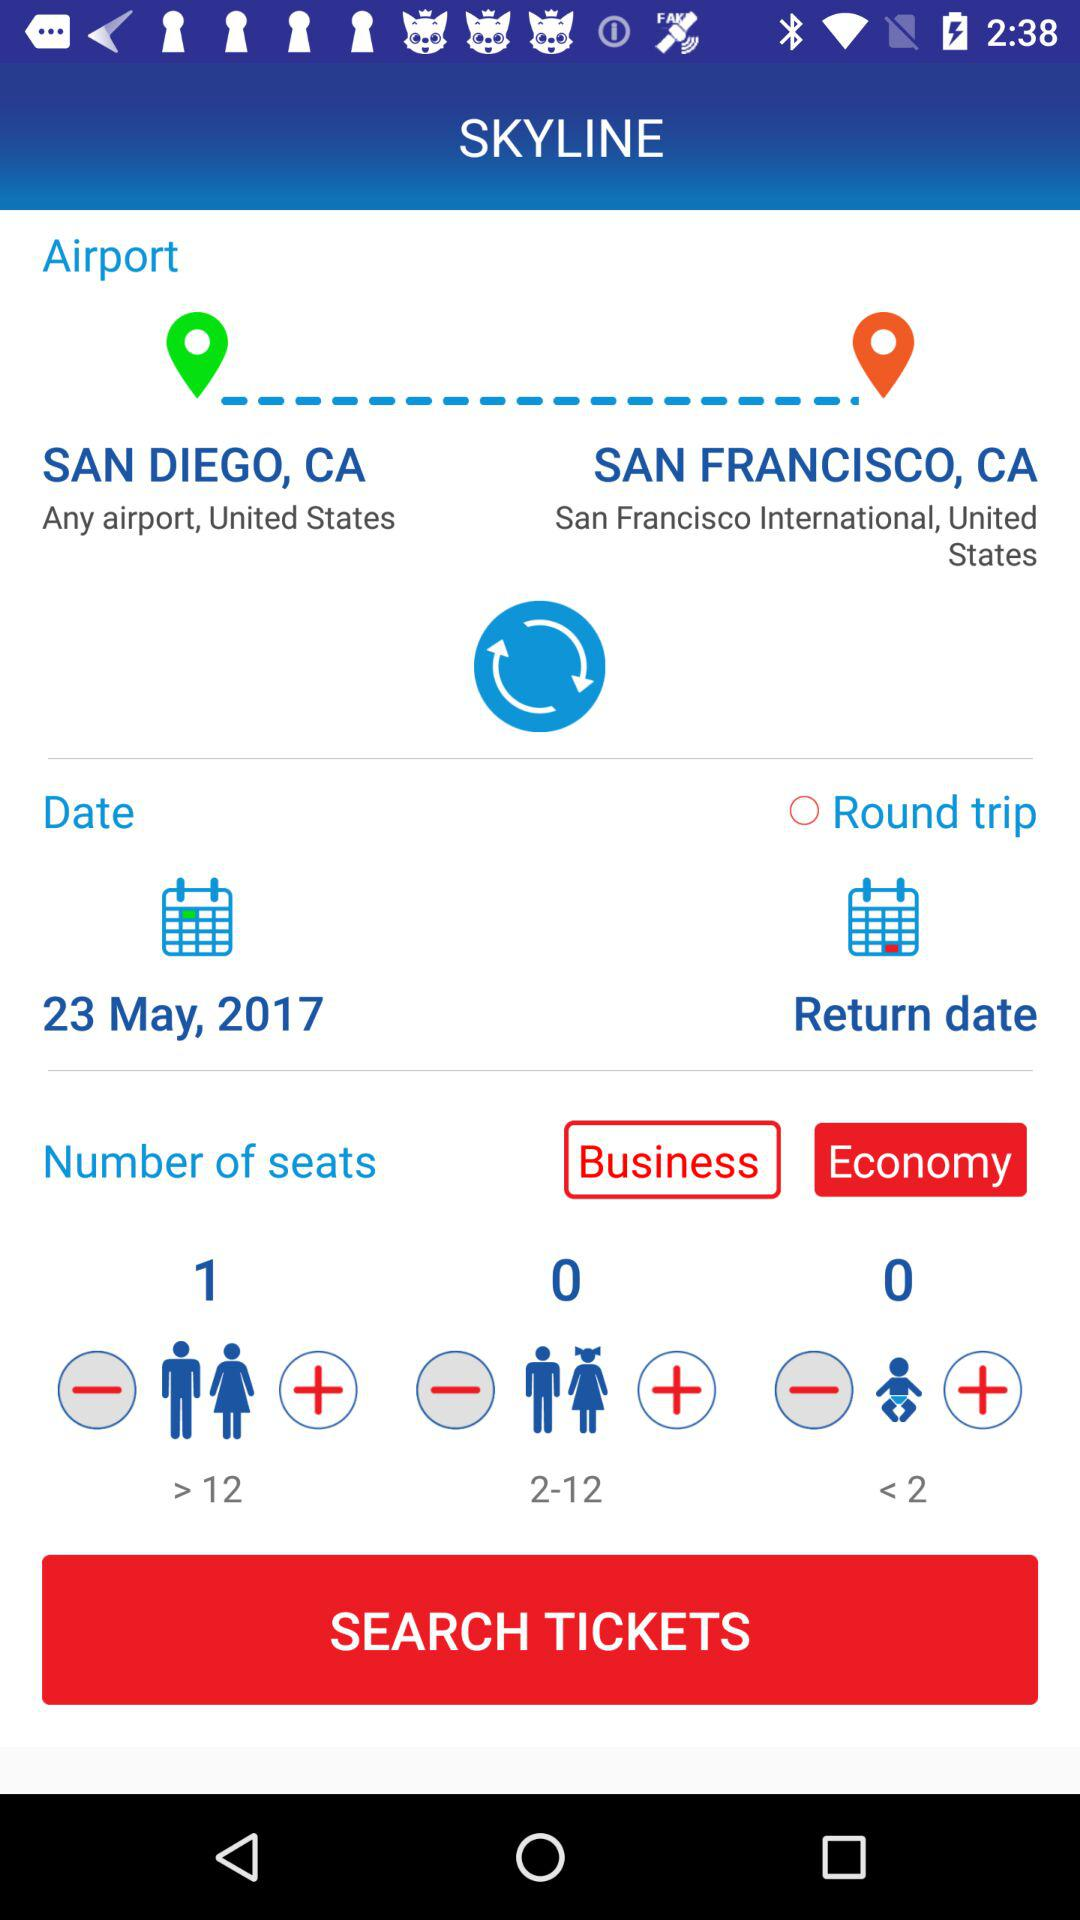What is the departure date? The departure date is May 23, 2017. 